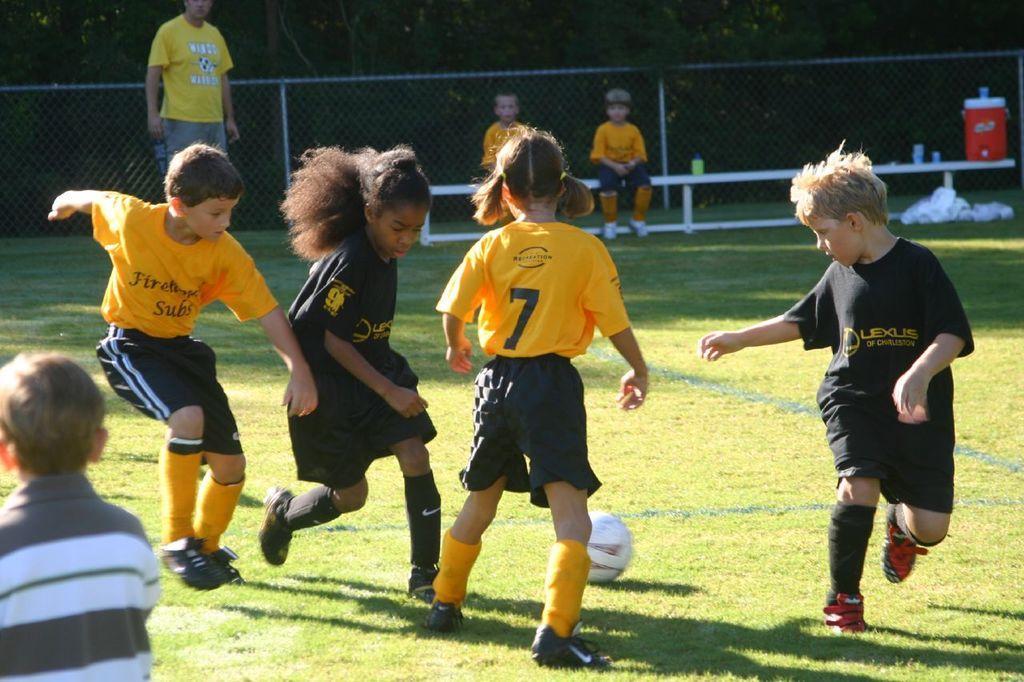Please provide a concise description of this image. In the picture I can see these children wearing yellow color T-shirts and black color T-shirts are playing on the ground. Here we can see a ball. On the left side of the image we can see a child wearing white and black stripes T-shirt, we can see two children wearing yellow T-shirts are sitting on the bench, we can see a person wearing a yellow T-shirt is standing, we can see the water can, fence and trees. 